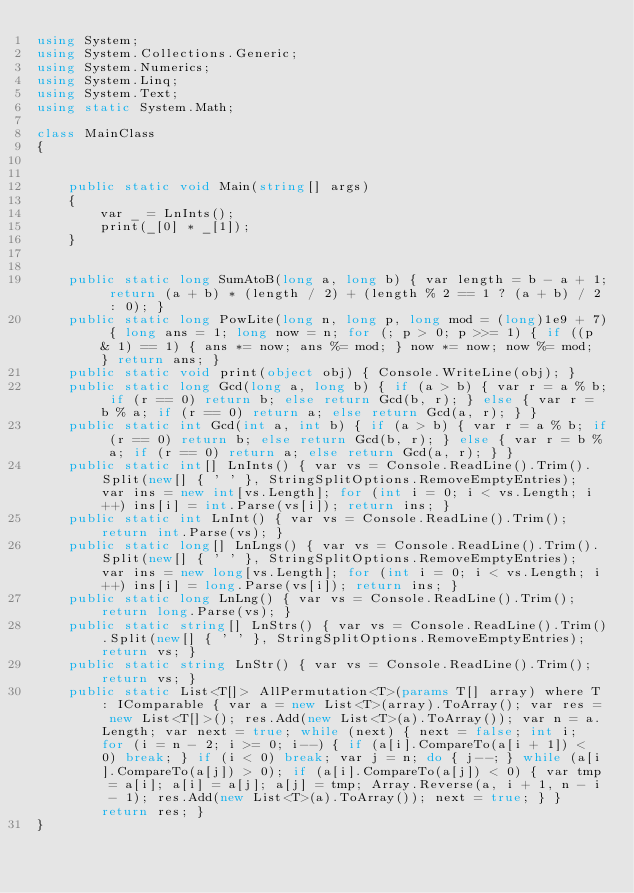Convert code to text. <code><loc_0><loc_0><loc_500><loc_500><_C#_>using System;
using System.Collections.Generic;
using System.Numerics;
using System.Linq;
using System.Text;
using static System.Math;

class MainClass
{


    public static void Main(string[] args)
    {
        var _ = LnInts();
        print(_[0] * _[1]);
    }


    public static long SumAtoB(long a, long b) { var length = b - a + 1; return (a + b) * (length / 2) + (length % 2 == 1 ? (a + b) / 2 : 0); }
    public static long PowLite(long n, long p, long mod = (long)1e9 + 7) { long ans = 1; long now = n; for (; p > 0; p >>= 1) { if ((p & 1) == 1) { ans *= now; ans %= mod; } now *= now; now %= mod; } return ans; }
    public static void print(object obj) { Console.WriteLine(obj); }
    public static long Gcd(long a, long b) { if (a > b) { var r = a % b; if (r == 0) return b; else return Gcd(b, r); } else { var r = b % a; if (r == 0) return a; else return Gcd(a, r); } }
    public static int Gcd(int a, int b) { if (a > b) { var r = a % b; if (r == 0) return b; else return Gcd(b, r); } else { var r = b % a; if (r == 0) return a; else return Gcd(a, r); } }
    public static int[] LnInts() { var vs = Console.ReadLine().Trim().Split(new[] { ' ' }, StringSplitOptions.RemoveEmptyEntries); var ins = new int[vs.Length]; for (int i = 0; i < vs.Length; i++) ins[i] = int.Parse(vs[i]); return ins; }
    public static int LnInt() { var vs = Console.ReadLine().Trim(); return int.Parse(vs); }
    public static long[] LnLngs() { var vs = Console.ReadLine().Trim().Split(new[] { ' ' }, StringSplitOptions.RemoveEmptyEntries); var ins = new long[vs.Length]; for (int i = 0; i < vs.Length; i++) ins[i] = long.Parse(vs[i]); return ins; }
    public static long LnLng() { var vs = Console.ReadLine().Trim(); return long.Parse(vs); }
    public static string[] LnStrs() { var vs = Console.ReadLine().Trim().Split(new[] { ' ' }, StringSplitOptions.RemoveEmptyEntries); return vs; }
    public static string LnStr() { var vs = Console.ReadLine().Trim(); return vs; }
    public static List<T[]> AllPermutation<T>(params T[] array) where T : IComparable { var a = new List<T>(array).ToArray(); var res = new List<T[]>(); res.Add(new List<T>(a).ToArray()); var n = a.Length; var next = true; while (next) { next = false; int i; for (i = n - 2; i >= 0; i--) { if (a[i].CompareTo(a[i + 1]) < 0) break; } if (i < 0) break; var j = n; do { j--; } while (a[i].CompareTo(a[j]) > 0); if (a[i].CompareTo(a[j]) < 0) { var tmp = a[i]; a[i] = a[j]; a[j] = tmp; Array.Reverse(a, i + 1, n - i - 1); res.Add(new List<T>(a).ToArray()); next = true; } } return res; }
}
</code> 